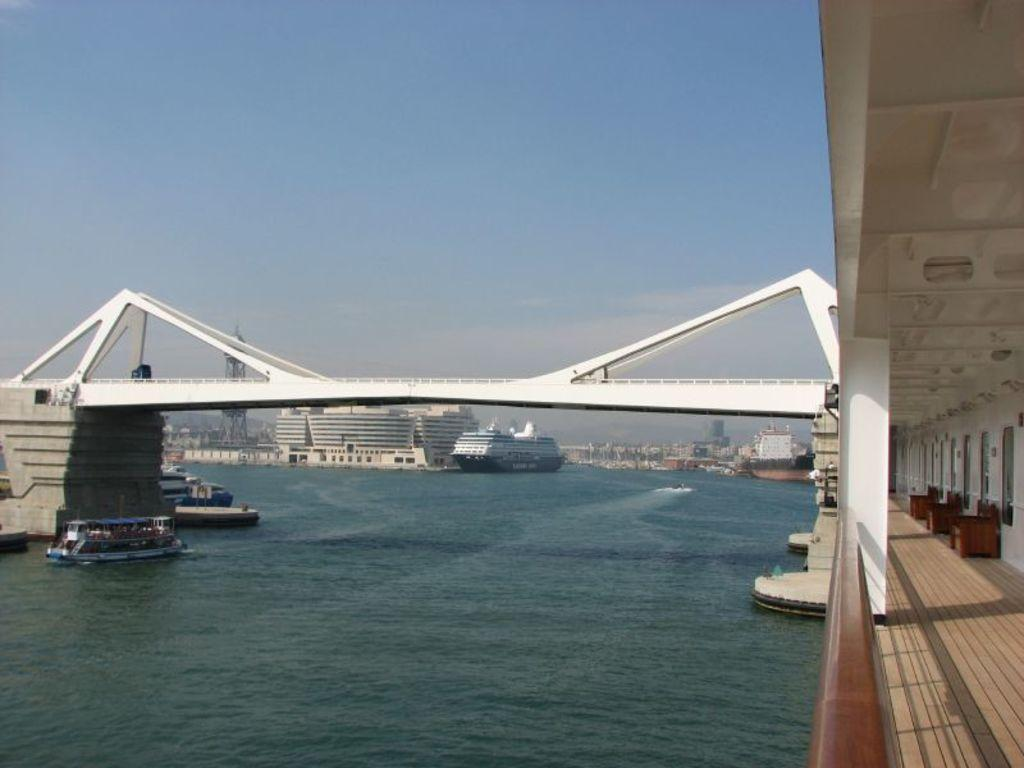What is on the water in the image? There are boats on the water in the image. What structure can be seen in the image? There is a bridge in the image. What is the color of the bridge? The bridge is white in color. What can be seen in the background of the image? There are buildings in the background of the image. What is the color of the buildings? The buildings are white in color. What is the color of the sky in the image? The sky is blue in color. How many lizards are crawling on the bridge in the image? There are no lizards present in the image. What type of cap is the person wearing on the boat in the image? There are no people or caps visible in the image. 